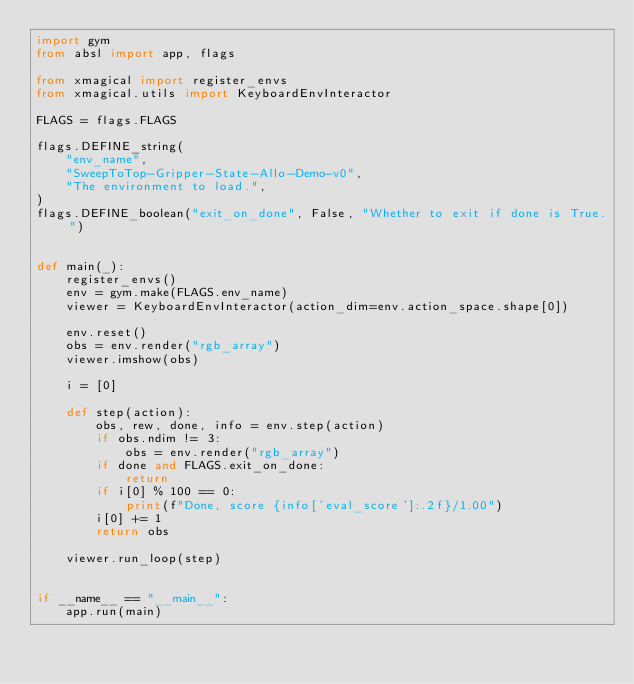<code> <loc_0><loc_0><loc_500><loc_500><_Python_>import gym
from absl import app, flags

from xmagical import register_envs
from xmagical.utils import KeyboardEnvInteractor

FLAGS = flags.FLAGS

flags.DEFINE_string(
    "env_name",
    "SweepToTop-Gripper-State-Allo-Demo-v0",
    "The environment to load.",
)
flags.DEFINE_boolean("exit_on_done", False, "Whether to exit if done is True.")


def main(_):
    register_envs()
    env = gym.make(FLAGS.env_name)
    viewer = KeyboardEnvInteractor(action_dim=env.action_space.shape[0])

    env.reset()
    obs = env.render("rgb_array")
    viewer.imshow(obs)

    i = [0]

    def step(action):
        obs, rew, done, info = env.step(action)
        if obs.ndim != 3:
            obs = env.render("rgb_array")
        if done and FLAGS.exit_on_done:
            return
        if i[0] % 100 == 0:
            print(f"Done, score {info['eval_score']:.2f}/1.00")
        i[0] += 1
        return obs

    viewer.run_loop(step)


if __name__ == "__main__":
    app.run(main)
</code> 